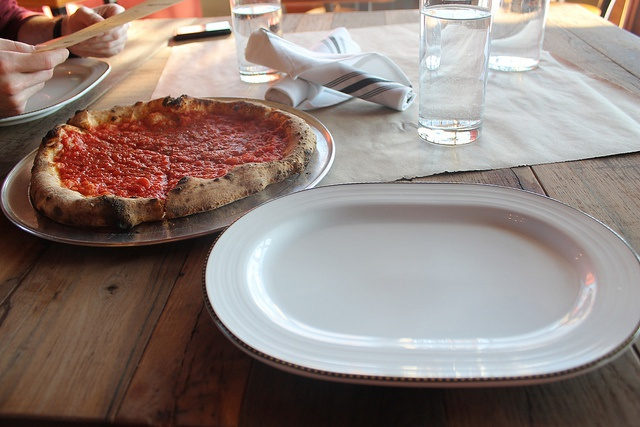Describe the objects in this image and their specific colors. I can see dining table in lightgray, darkgray, black, maroon, and brown tones, pizza in brown, maroon, and black tones, cup in brown, lightgray, and darkgray tones, people in brown, maroon, and tan tones, and cup in brown, lightgray, darkgray, and tan tones in this image. 